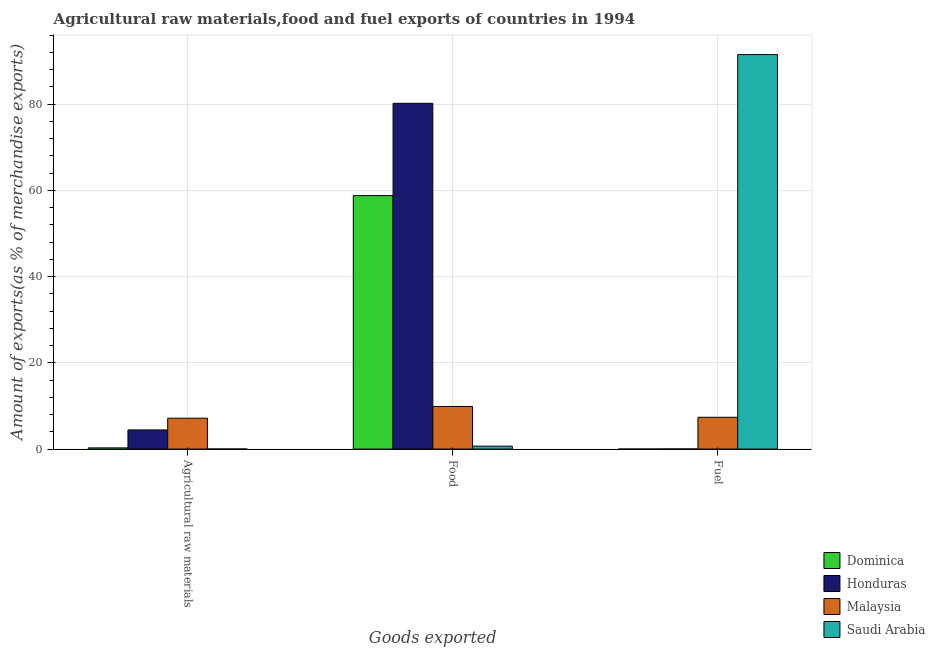How many different coloured bars are there?
Offer a terse response. 4. Are the number of bars per tick equal to the number of legend labels?
Give a very brief answer. Yes. How many bars are there on the 2nd tick from the left?
Your answer should be compact. 4. How many bars are there on the 1st tick from the right?
Provide a short and direct response. 4. What is the label of the 2nd group of bars from the left?
Give a very brief answer. Food. What is the percentage of food exports in Dominica?
Make the answer very short. 58.78. Across all countries, what is the maximum percentage of raw materials exports?
Provide a succinct answer. 7.16. Across all countries, what is the minimum percentage of raw materials exports?
Your answer should be very brief. 0.01. In which country was the percentage of raw materials exports maximum?
Provide a succinct answer. Malaysia. In which country was the percentage of raw materials exports minimum?
Give a very brief answer. Saudi Arabia. What is the total percentage of fuel exports in the graph?
Your answer should be compact. 98.87. What is the difference between the percentage of food exports in Malaysia and that in Dominica?
Offer a terse response. -48.9. What is the difference between the percentage of fuel exports in Saudi Arabia and the percentage of food exports in Honduras?
Give a very brief answer. 11.3. What is the average percentage of raw materials exports per country?
Provide a short and direct response. 2.97. What is the difference between the percentage of food exports and percentage of fuel exports in Saudi Arabia?
Provide a short and direct response. -90.8. In how many countries, is the percentage of raw materials exports greater than 68 %?
Make the answer very short. 0. What is the ratio of the percentage of food exports in Malaysia to that in Dominica?
Ensure brevity in your answer.  0.17. What is the difference between the highest and the second highest percentage of food exports?
Your answer should be compact. 21.4. What is the difference between the highest and the lowest percentage of fuel exports?
Keep it short and to the point. 91.48. In how many countries, is the percentage of food exports greater than the average percentage of food exports taken over all countries?
Make the answer very short. 2. Is the sum of the percentage of raw materials exports in Saudi Arabia and Malaysia greater than the maximum percentage of food exports across all countries?
Provide a succinct answer. No. What does the 1st bar from the left in Agricultural raw materials represents?
Give a very brief answer. Dominica. What does the 2nd bar from the right in Agricultural raw materials represents?
Your answer should be compact. Malaysia. Is it the case that in every country, the sum of the percentage of raw materials exports and percentage of food exports is greater than the percentage of fuel exports?
Offer a terse response. No. Are all the bars in the graph horizontal?
Provide a short and direct response. No. Are the values on the major ticks of Y-axis written in scientific E-notation?
Your response must be concise. No. Does the graph contain any zero values?
Make the answer very short. No. How are the legend labels stacked?
Offer a terse response. Vertical. What is the title of the graph?
Ensure brevity in your answer.  Agricultural raw materials,food and fuel exports of countries in 1994. What is the label or title of the X-axis?
Keep it short and to the point. Goods exported. What is the label or title of the Y-axis?
Your answer should be compact. Amount of exports(as % of merchandise exports). What is the Amount of exports(as % of merchandise exports) in Dominica in Agricultural raw materials?
Offer a very short reply. 0.27. What is the Amount of exports(as % of merchandise exports) in Honduras in Agricultural raw materials?
Keep it short and to the point. 4.44. What is the Amount of exports(as % of merchandise exports) of Malaysia in Agricultural raw materials?
Ensure brevity in your answer.  7.16. What is the Amount of exports(as % of merchandise exports) of Saudi Arabia in Agricultural raw materials?
Your answer should be compact. 0.01. What is the Amount of exports(as % of merchandise exports) in Dominica in Food?
Your answer should be very brief. 58.78. What is the Amount of exports(as % of merchandise exports) in Honduras in Food?
Your answer should be very brief. 80.18. What is the Amount of exports(as % of merchandise exports) of Malaysia in Food?
Provide a succinct answer. 9.88. What is the Amount of exports(as % of merchandise exports) in Saudi Arabia in Food?
Provide a short and direct response. 0.67. What is the Amount of exports(as % of merchandise exports) of Dominica in Fuel?
Provide a short and direct response. 0. What is the Amount of exports(as % of merchandise exports) in Honduras in Fuel?
Ensure brevity in your answer.  0.02. What is the Amount of exports(as % of merchandise exports) of Malaysia in Fuel?
Offer a very short reply. 7.37. What is the Amount of exports(as % of merchandise exports) in Saudi Arabia in Fuel?
Ensure brevity in your answer.  91.48. Across all Goods exported, what is the maximum Amount of exports(as % of merchandise exports) of Dominica?
Offer a terse response. 58.78. Across all Goods exported, what is the maximum Amount of exports(as % of merchandise exports) in Honduras?
Your response must be concise. 80.18. Across all Goods exported, what is the maximum Amount of exports(as % of merchandise exports) in Malaysia?
Offer a terse response. 9.88. Across all Goods exported, what is the maximum Amount of exports(as % of merchandise exports) of Saudi Arabia?
Your response must be concise. 91.48. Across all Goods exported, what is the minimum Amount of exports(as % of merchandise exports) of Dominica?
Your answer should be very brief. 0. Across all Goods exported, what is the minimum Amount of exports(as % of merchandise exports) in Honduras?
Make the answer very short. 0.02. Across all Goods exported, what is the minimum Amount of exports(as % of merchandise exports) in Malaysia?
Your answer should be very brief. 7.16. Across all Goods exported, what is the minimum Amount of exports(as % of merchandise exports) of Saudi Arabia?
Your answer should be very brief. 0.01. What is the total Amount of exports(as % of merchandise exports) in Dominica in the graph?
Your answer should be very brief. 59.06. What is the total Amount of exports(as % of merchandise exports) in Honduras in the graph?
Your answer should be very brief. 84.64. What is the total Amount of exports(as % of merchandise exports) in Malaysia in the graph?
Your answer should be compact. 24.41. What is the total Amount of exports(as % of merchandise exports) of Saudi Arabia in the graph?
Make the answer very short. 92.16. What is the difference between the Amount of exports(as % of merchandise exports) in Dominica in Agricultural raw materials and that in Food?
Keep it short and to the point. -58.51. What is the difference between the Amount of exports(as % of merchandise exports) of Honduras in Agricultural raw materials and that in Food?
Offer a very short reply. -75.74. What is the difference between the Amount of exports(as % of merchandise exports) of Malaysia in Agricultural raw materials and that in Food?
Your answer should be compact. -2.72. What is the difference between the Amount of exports(as % of merchandise exports) in Saudi Arabia in Agricultural raw materials and that in Food?
Give a very brief answer. -0.66. What is the difference between the Amount of exports(as % of merchandise exports) of Dominica in Agricultural raw materials and that in Fuel?
Keep it short and to the point. 0.27. What is the difference between the Amount of exports(as % of merchandise exports) of Honduras in Agricultural raw materials and that in Fuel?
Provide a short and direct response. 4.42. What is the difference between the Amount of exports(as % of merchandise exports) of Malaysia in Agricultural raw materials and that in Fuel?
Make the answer very short. -0.21. What is the difference between the Amount of exports(as % of merchandise exports) of Saudi Arabia in Agricultural raw materials and that in Fuel?
Keep it short and to the point. -91.46. What is the difference between the Amount of exports(as % of merchandise exports) in Dominica in Food and that in Fuel?
Make the answer very short. 58.78. What is the difference between the Amount of exports(as % of merchandise exports) of Honduras in Food and that in Fuel?
Your response must be concise. 80.16. What is the difference between the Amount of exports(as % of merchandise exports) of Malaysia in Food and that in Fuel?
Your answer should be very brief. 2.51. What is the difference between the Amount of exports(as % of merchandise exports) of Saudi Arabia in Food and that in Fuel?
Your response must be concise. -90.8. What is the difference between the Amount of exports(as % of merchandise exports) of Dominica in Agricultural raw materials and the Amount of exports(as % of merchandise exports) of Honduras in Food?
Provide a succinct answer. -79.9. What is the difference between the Amount of exports(as % of merchandise exports) of Dominica in Agricultural raw materials and the Amount of exports(as % of merchandise exports) of Malaysia in Food?
Offer a terse response. -9.61. What is the difference between the Amount of exports(as % of merchandise exports) of Dominica in Agricultural raw materials and the Amount of exports(as % of merchandise exports) of Saudi Arabia in Food?
Ensure brevity in your answer.  -0.4. What is the difference between the Amount of exports(as % of merchandise exports) in Honduras in Agricultural raw materials and the Amount of exports(as % of merchandise exports) in Malaysia in Food?
Provide a short and direct response. -5.44. What is the difference between the Amount of exports(as % of merchandise exports) in Honduras in Agricultural raw materials and the Amount of exports(as % of merchandise exports) in Saudi Arabia in Food?
Keep it short and to the point. 3.76. What is the difference between the Amount of exports(as % of merchandise exports) in Malaysia in Agricultural raw materials and the Amount of exports(as % of merchandise exports) in Saudi Arabia in Food?
Provide a short and direct response. 6.49. What is the difference between the Amount of exports(as % of merchandise exports) of Dominica in Agricultural raw materials and the Amount of exports(as % of merchandise exports) of Honduras in Fuel?
Make the answer very short. 0.25. What is the difference between the Amount of exports(as % of merchandise exports) in Dominica in Agricultural raw materials and the Amount of exports(as % of merchandise exports) in Malaysia in Fuel?
Your answer should be compact. -7.1. What is the difference between the Amount of exports(as % of merchandise exports) in Dominica in Agricultural raw materials and the Amount of exports(as % of merchandise exports) in Saudi Arabia in Fuel?
Provide a succinct answer. -91.2. What is the difference between the Amount of exports(as % of merchandise exports) in Honduras in Agricultural raw materials and the Amount of exports(as % of merchandise exports) in Malaysia in Fuel?
Provide a short and direct response. -2.93. What is the difference between the Amount of exports(as % of merchandise exports) of Honduras in Agricultural raw materials and the Amount of exports(as % of merchandise exports) of Saudi Arabia in Fuel?
Your response must be concise. -87.04. What is the difference between the Amount of exports(as % of merchandise exports) of Malaysia in Agricultural raw materials and the Amount of exports(as % of merchandise exports) of Saudi Arabia in Fuel?
Offer a terse response. -84.32. What is the difference between the Amount of exports(as % of merchandise exports) of Dominica in Food and the Amount of exports(as % of merchandise exports) of Honduras in Fuel?
Your answer should be compact. 58.76. What is the difference between the Amount of exports(as % of merchandise exports) of Dominica in Food and the Amount of exports(as % of merchandise exports) of Malaysia in Fuel?
Your answer should be very brief. 51.41. What is the difference between the Amount of exports(as % of merchandise exports) of Dominica in Food and the Amount of exports(as % of merchandise exports) of Saudi Arabia in Fuel?
Offer a very short reply. -32.69. What is the difference between the Amount of exports(as % of merchandise exports) of Honduras in Food and the Amount of exports(as % of merchandise exports) of Malaysia in Fuel?
Make the answer very short. 72.81. What is the difference between the Amount of exports(as % of merchandise exports) in Honduras in Food and the Amount of exports(as % of merchandise exports) in Saudi Arabia in Fuel?
Provide a succinct answer. -11.3. What is the difference between the Amount of exports(as % of merchandise exports) in Malaysia in Food and the Amount of exports(as % of merchandise exports) in Saudi Arabia in Fuel?
Make the answer very short. -81.59. What is the average Amount of exports(as % of merchandise exports) of Dominica per Goods exported?
Your response must be concise. 19.69. What is the average Amount of exports(as % of merchandise exports) of Honduras per Goods exported?
Your answer should be compact. 28.21. What is the average Amount of exports(as % of merchandise exports) in Malaysia per Goods exported?
Provide a short and direct response. 8.14. What is the average Amount of exports(as % of merchandise exports) of Saudi Arabia per Goods exported?
Give a very brief answer. 30.72. What is the difference between the Amount of exports(as % of merchandise exports) of Dominica and Amount of exports(as % of merchandise exports) of Honduras in Agricultural raw materials?
Your answer should be compact. -4.16. What is the difference between the Amount of exports(as % of merchandise exports) in Dominica and Amount of exports(as % of merchandise exports) in Malaysia in Agricultural raw materials?
Your answer should be compact. -6.89. What is the difference between the Amount of exports(as % of merchandise exports) of Dominica and Amount of exports(as % of merchandise exports) of Saudi Arabia in Agricultural raw materials?
Your answer should be compact. 0.26. What is the difference between the Amount of exports(as % of merchandise exports) of Honduras and Amount of exports(as % of merchandise exports) of Malaysia in Agricultural raw materials?
Ensure brevity in your answer.  -2.72. What is the difference between the Amount of exports(as % of merchandise exports) of Honduras and Amount of exports(as % of merchandise exports) of Saudi Arabia in Agricultural raw materials?
Give a very brief answer. 4.42. What is the difference between the Amount of exports(as % of merchandise exports) in Malaysia and Amount of exports(as % of merchandise exports) in Saudi Arabia in Agricultural raw materials?
Your answer should be very brief. 7.15. What is the difference between the Amount of exports(as % of merchandise exports) in Dominica and Amount of exports(as % of merchandise exports) in Honduras in Food?
Provide a short and direct response. -21.4. What is the difference between the Amount of exports(as % of merchandise exports) in Dominica and Amount of exports(as % of merchandise exports) in Malaysia in Food?
Provide a succinct answer. 48.9. What is the difference between the Amount of exports(as % of merchandise exports) of Dominica and Amount of exports(as % of merchandise exports) of Saudi Arabia in Food?
Make the answer very short. 58.11. What is the difference between the Amount of exports(as % of merchandise exports) in Honduras and Amount of exports(as % of merchandise exports) in Malaysia in Food?
Provide a short and direct response. 70.3. What is the difference between the Amount of exports(as % of merchandise exports) of Honduras and Amount of exports(as % of merchandise exports) of Saudi Arabia in Food?
Make the answer very short. 79.5. What is the difference between the Amount of exports(as % of merchandise exports) of Malaysia and Amount of exports(as % of merchandise exports) of Saudi Arabia in Food?
Make the answer very short. 9.21. What is the difference between the Amount of exports(as % of merchandise exports) in Dominica and Amount of exports(as % of merchandise exports) in Honduras in Fuel?
Provide a short and direct response. -0.02. What is the difference between the Amount of exports(as % of merchandise exports) in Dominica and Amount of exports(as % of merchandise exports) in Malaysia in Fuel?
Your response must be concise. -7.37. What is the difference between the Amount of exports(as % of merchandise exports) of Dominica and Amount of exports(as % of merchandise exports) of Saudi Arabia in Fuel?
Provide a succinct answer. -91.48. What is the difference between the Amount of exports(as % of merchandise exports) of Honduras and Amount of exports(as % of merchandise exports) of Malaysia in Fuel?
Keep it short and to the point. -7.35. What is the difference between the Amount of exports(as % of merchandise exports) in Honduras and Amount of exports(as % of merchandise exports) in Saudi Arabia in Fuel?
Ensure brevity in your answer.  -91.45. What is the difference between the Amount of exports(as % of merchandise exports) of Malaysia and Amount of exports(as % of merchandise exports) of Saudi Arabia in Fuel?
Give a very brief answer. -84.11. What is the ratio of the Amount of exports(as % of merchandise exports) in Dominica in Agricultural raw materials to that in Food?
Provide a short and direct response. 0. What is the ratio of the Amount of exports(as % of merchandise exports) of Honduras in Agricultural raw materials to that in Food?
Offer a terse response. 0.06. What is the ratio of the Amount of exports(as % of merchandise exports) of Malaysia in Agricultural raw materials to that in Food?
Make the answer very short. 0.72. What is the ratio of the Amount of exports(as % of merchandise exports) in Saudi Arabia in Agricultural raw materials to that in Food?
Your answer should be very brief. 0.02. What is the ratio of the Amount of exports(as % of merchandise exports) in Dominica in Agricultural raw materials to that in Fuel?
Provide a short and direct response. 312.62. What is the ratio of the Amount of exports(as % of merchandise exports) of Honduras in Agricultural raw materials to that in Fuel?
Give a very brief answer. 204.38. What is the ratio of the Amount of exports(as % of merchandise exports) of Malaysia in Agricultural raw materials to that in Fuel?
Provide a succinct answer. 0.97. What is the ratio of the Amount of exports(as % of merchandise exports) in Saudi Arabia in Agricultural raw materials to that in Fuel?
Your response must be concise. 0. What is the ratio of the Amount of exports(as % of merchandise exports) in Dominica in Food to that in Fuel?
Your answer should be compact. 6.69e+04. What is the ratio of the Amount of exports(as % of merchandise exports) in Honduras in Food to that in Fuel?
Offer a very short reply. 3693.21. What is the ratio of the Amount of exports(as % of merchandise exports) in Malaysia in Food to that in Fuel?
Give a very brief answer. 1.34. What is the ratio of the Amount of exports(as % of merchandise exports) in Saudi Arabia in Food to that in Fuel?
Make the answer very short. 0.01. What is the difference between the highest and the second highest Amount of exports(as % of merchandise exports) of Dominica?
Offer a terse response. 58.51. What is the difference between the highest and the second highest Amount of exports(as % of merchandise exports) of Honduras?
Ensure brevity in your answer.  75.74. What is the difference between the highest and the second highest Amount of exports(as % of merchandise exports) of Malaysia?
Offer a terse response. 2.51. What is the difference between the highest and the second highest Amount of exports(as % of merchandise exports) in Saudi Arabia?
Ensure brevity in your answer.  90.8. What is the difference between the highest and the lowest Amount of exports(as % of merchandise exports) of Dominica?
Make the answer very short. 58.78. What is the difference between the highest and the lowest Amount of exports(as % of merchandise exports) in Honduras?
Ensure brevity in your answer.  80.16. What is the difference between the highest and the lowest Amount of exports(as % of merchandise exports) in Malaysia?
Ensure brevity in your answer.  2.72. What is the difference between the highest and the lowest Amount of exports(as % of merchandise exports) of Saudi Arabia?
Provide a short and direct response. 91.46. 